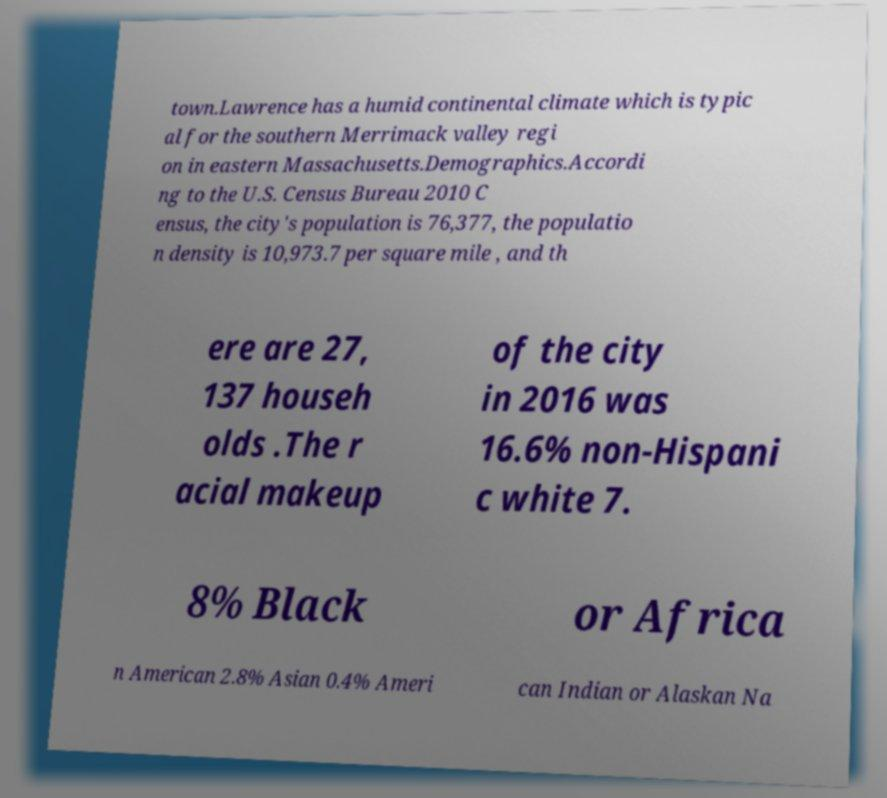I need the written content from this picture converted into text. Can you do that? town.Lawrence has a humid continental climate which is typic al for the southern Merrimack valley regi on in eastern Massachusetts.Demographics.Accordi ng to the U.S. Census Bureau 2010 C ensus, the city's population is 76,377, the populatio n density is 10,973.7 per square mile , and th ere are 27, 137 househ olds .The r acial makeup of the city in 2016 was 16.6% non-Hispani c white 7. 8% Black or Africa n American 2.8% Asian 0.4% Ameri can Indian or Alaskan Na 